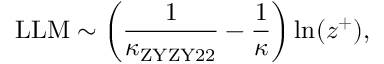<formula> <loc_0><loc_0><loc_500><loc_500>L L M \sim \left ( \frac { 1 } { \kappa _ { Z Y Z Y 2 2 } } - \frac { 1 } { \kappa } \right ) \ln ( z ^ { + } ) ,</formula> 